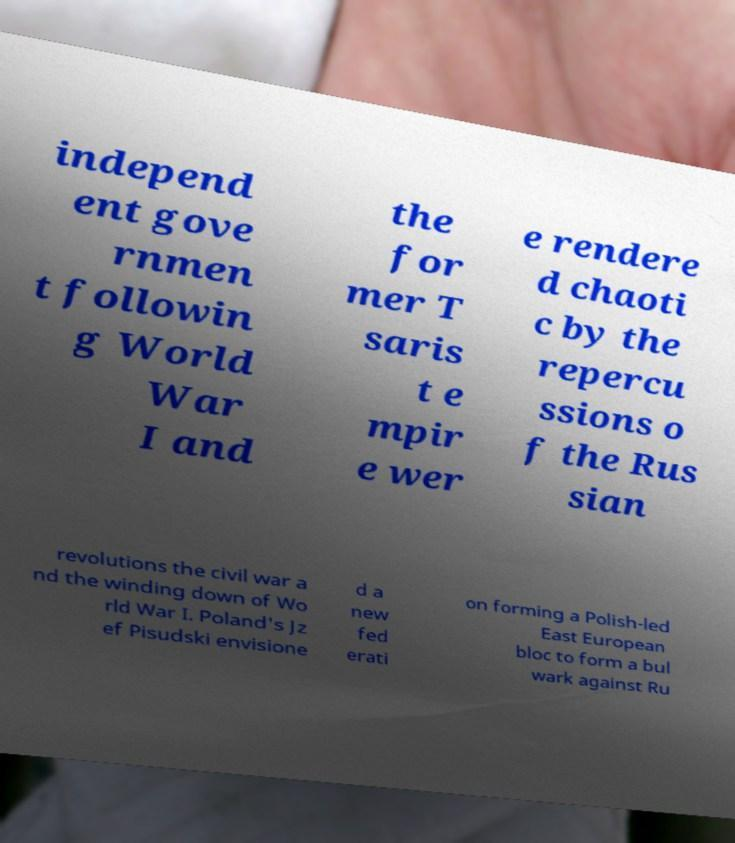Can you read and provide the text displayed in the image?This photo seems to have some interesting text. Can you extract and type it out for me? independ ent gove rnmen t followin g World War I and the for mer T saris t e mpir e wer e rendere d chaoti c by the repercu ssions o f the Rus sian revolutions the civil war a nd the winding down of Wo rld War I. Poland's Jz ef Pisudski envisione d a new fed erati on forming a Polish-led East European bloc to form a bul wark against Ru 